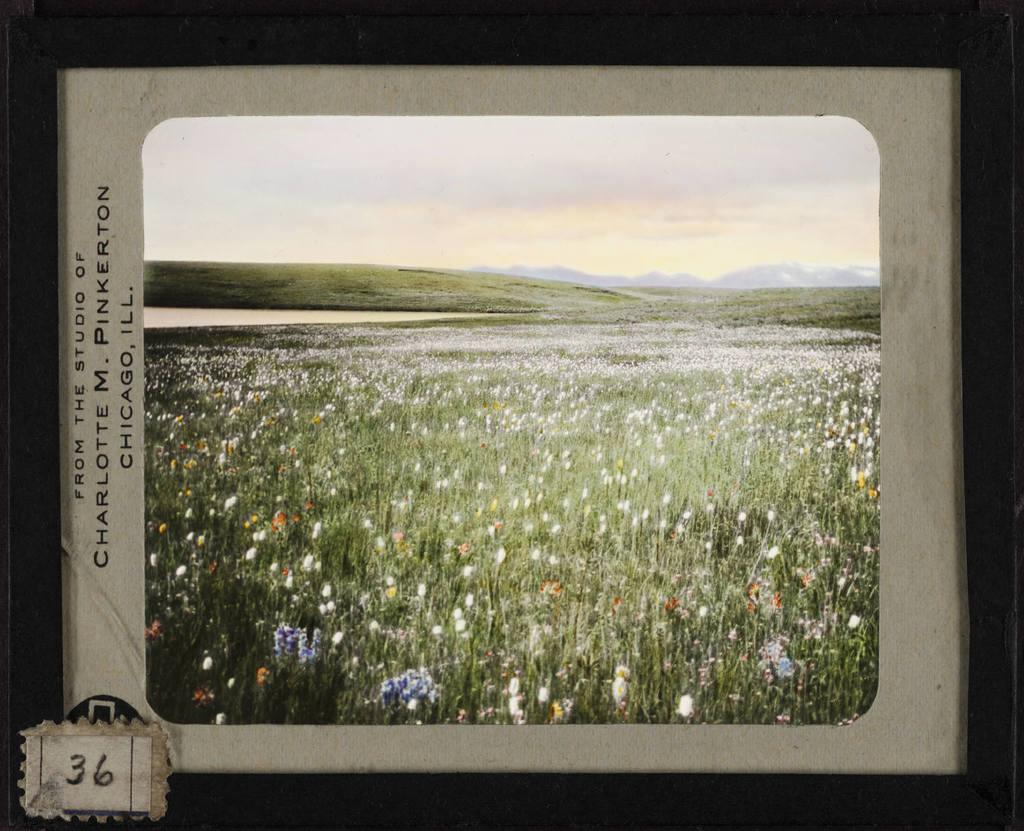<image>
Summarize the visual content of the image. A picture of a field labeled Chicago Ill. 